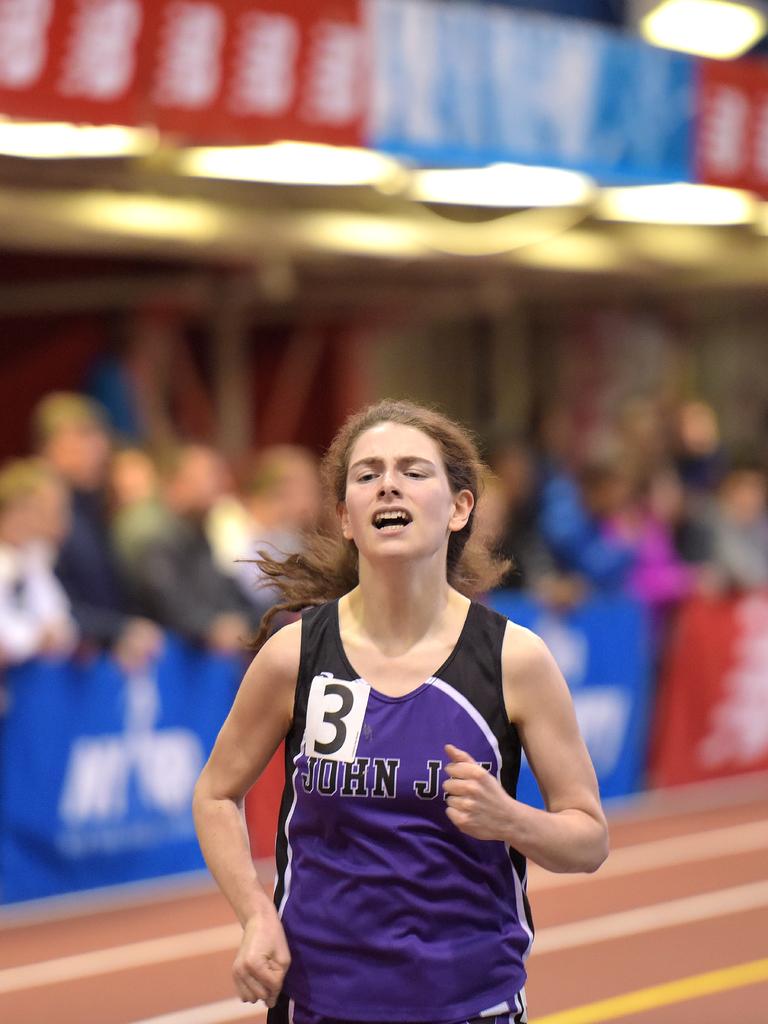What is the first word on her shirt?
Your response must be concise. John. What is the number?
Provide a succinct answer. 3. 